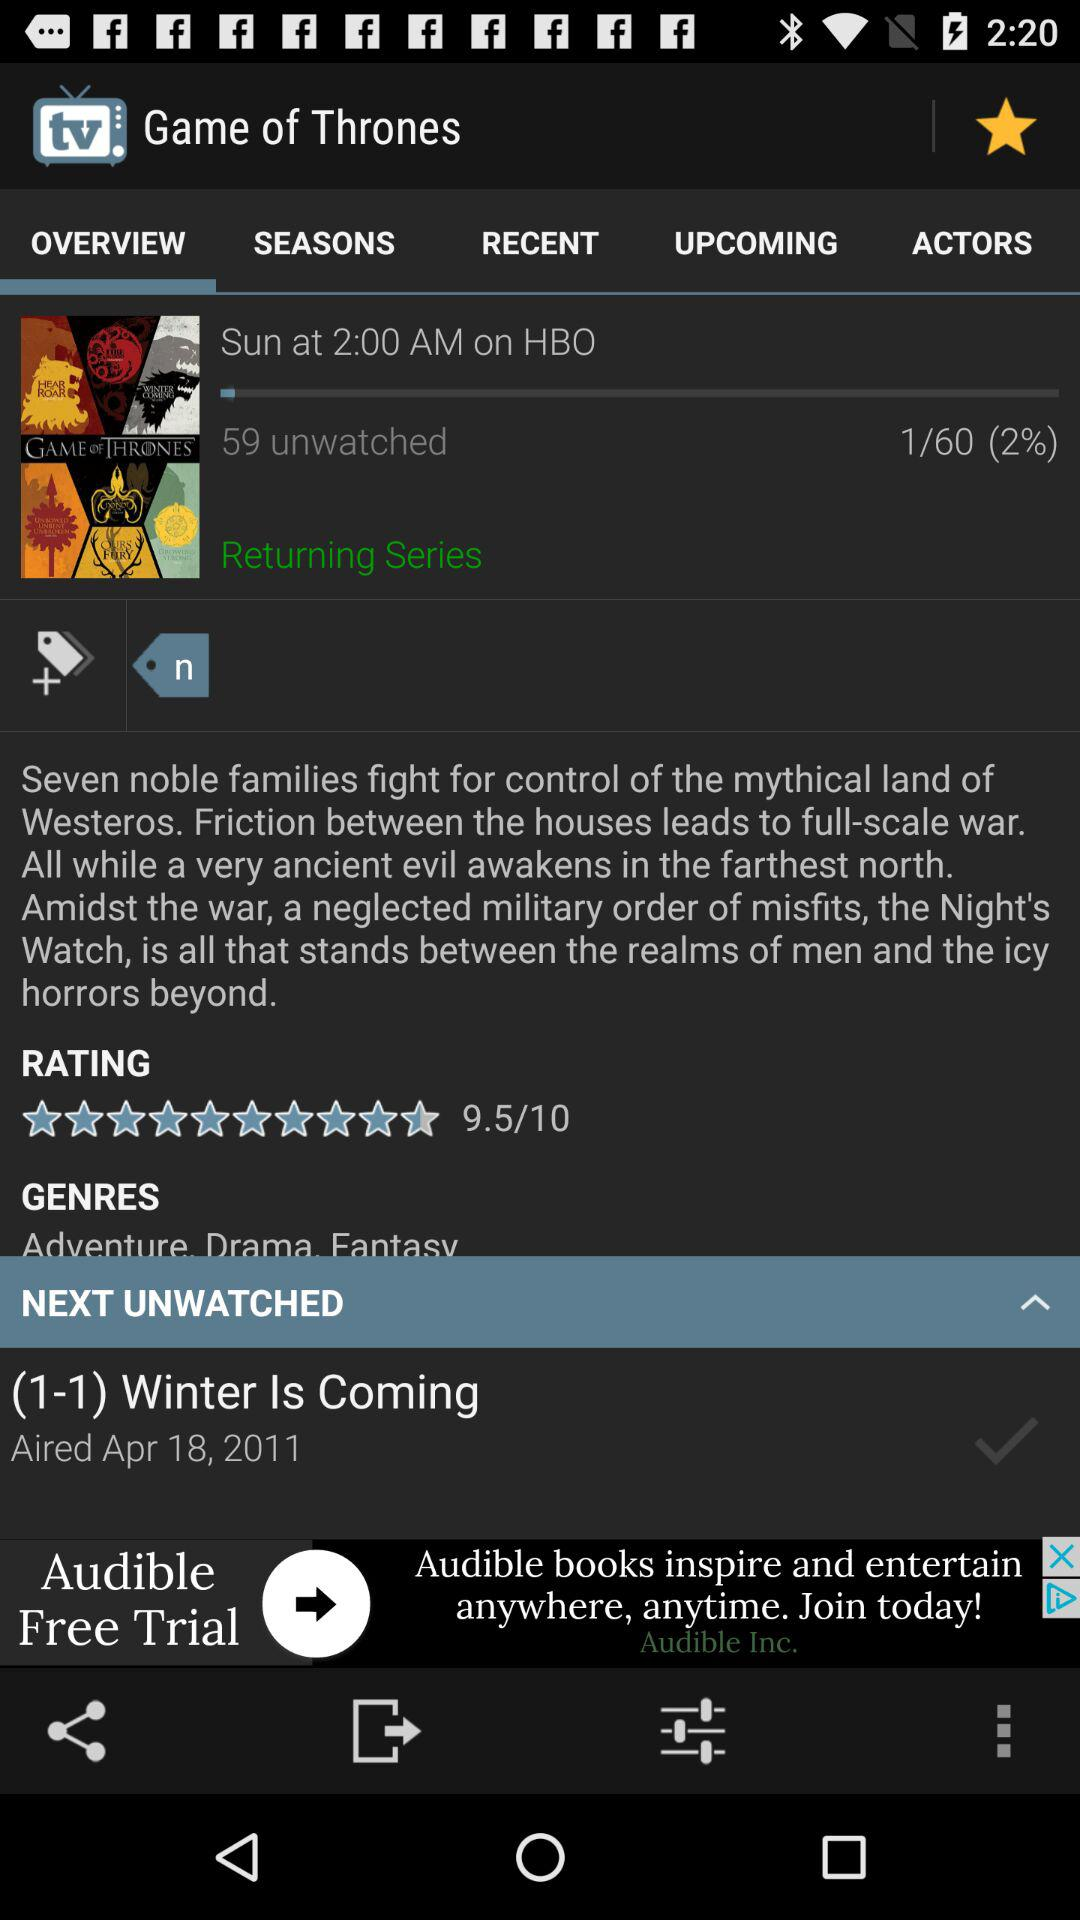What is the given time? The given time is 2:00 AM. 